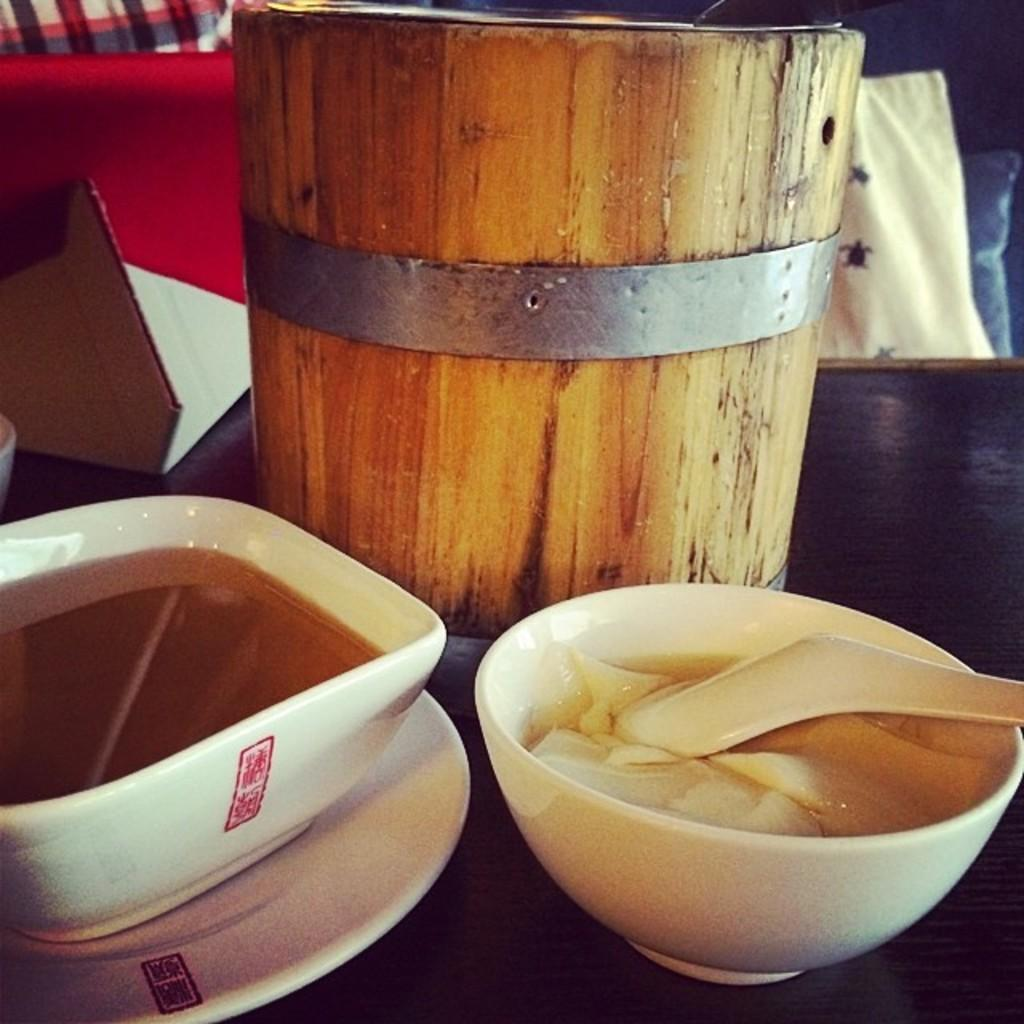What type of dishware is present in the image? There are bowls and a saucer in the image. What utensil can be seen in the image? There is a spoon in the image. What type of container is present in the image? There is a wooden box in the image. What grade is the wooden box in the image? The wooden box is not a student or a grade; it is a container. What type of tool is used for tightening or loosening bolts in the image? There is no wrench present in the image. 